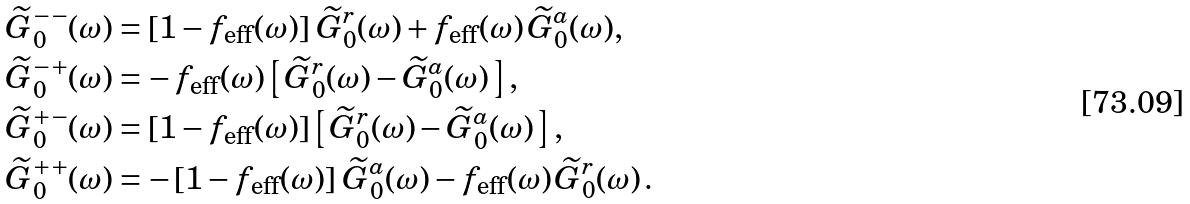<formula> <loc_0><loc_0><loc_500><loc_500>& \, \widetilde { G } _ { 0 } ^ { - - } ( \omega ) = \left [ 1 - f _ { \text {eff} } ( \omega ) \right ] \, \widetilde { G } _ { 0 } ^ { r } ( \omega ) + f _ { \text {eff} } ( \omega ) \, \widetilde { G } _ { 0 } ^ { a } ( \omega ) , \\ & \, \widetilde { G } _ { 0 } ^ { - + } ( \omega ) = - \, f _ { \text {eff} } ( \omega ) \left [ \, \widetilde { G } _ { 0 } ^ { r } ( \omega ) - \widetilde { G } _ { 0 } ^ { a } ( \omega ) \, \right ] , \\ & \, \widetilde { G } _ { 0 } ^ { + - } ( \omega ) = \left [ 1 - f _ { \text {eff} } ( \omega ) \right ] \left [ \, \widetilde { G } _ { 0 } ^ { r } ( \omega ) - \widetilde { G } _ { 0 } ^ { a } ( \omega ) \, \right ] , \\ & \, \widetilde { G } _ { 0 } ^ { + + } ( \omega ) = - \left [ 1 - f _ { \text {eff} } ( \omega ) \right ] \, \widetilde { G } _ { 0 } ^ { a } ( \omega ) - f _ { \text {eff} } ( \omega ) \, \widetilde { G } _ { 0 } ^ { r } ( \omega ) \, .</formula> 